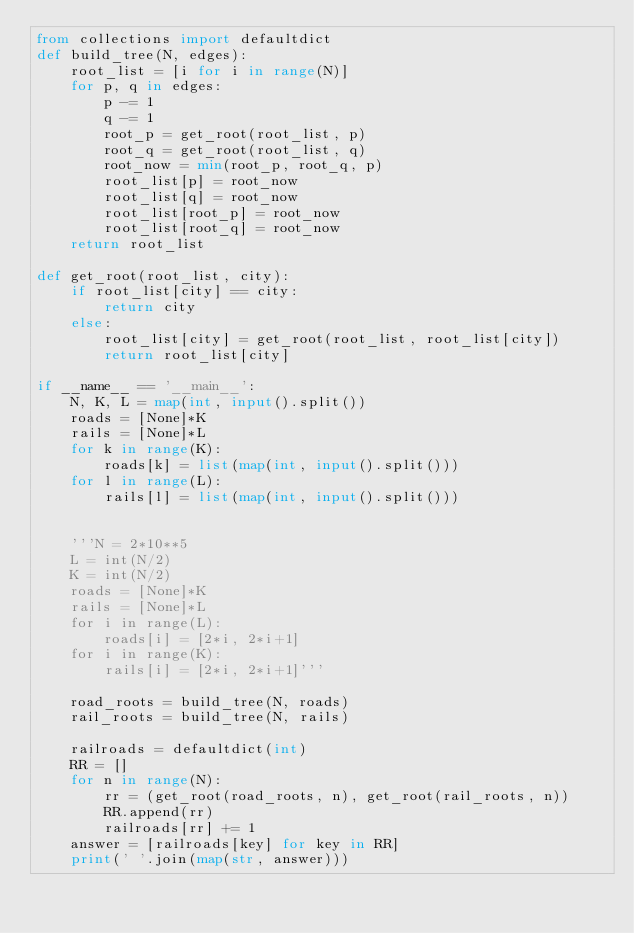<code> <loc_0><loc_0><loc_500><loc_500><_Python_>from collections import defaultdict
def build_tree(N, edges):
    root_list = [i for i in range(N)]
    for p, q in edges:
        p -= 1
        q -= 1
        root_p = get_root(root_list, p)
        root_q = get_root(root_list, q)
        root_now = min(root_p, root_q, p)
        root_list[p] = root_now
        root_list[q] = root_now
        root_list[root_p] = root_now
        root_list[root_q] = root_now
    return root_list

def get_root(root_list, city):
    if root_list[city] == city:
        return city
    else: 
        root_list[city] = get_root(root_list, root_list[city])
        return root_list[city]

if __name__ == '__main__':
    N, K, L = map(int, input().split())
    roads = [None]*K
    rails = [None]*L
    for k in range(K):
        roads[k] = list(map(int, input().split()))
    for l in range(L):
        rails[l] = list(map(int, input().split()))
    
    
    '''N = 2*10**5
    L = int(N/2)
    K = int(N/2)
    roads = [None]*K
    rails = [None]*L
    for i in range(L):
        roads[i] = [2*i, 2*i+1]
    for i in range(K):
        rails[i] = [2*i, 2*i+1]'''
    
    road_roots = build_tree(N, roads)
    rail_roots = build_tree(N, rails)
    
    railroads = defaultdict(int)
    RR = []
    for n in range(N):
        rr = (get_root(road_roots, n), get_root(rail_roots, n))
        RR.append(rr)
        railroads[rr] += 1
    answer = [railroads[key] for key in RR]
    print(' '.join(map(str, answer)))</code> 